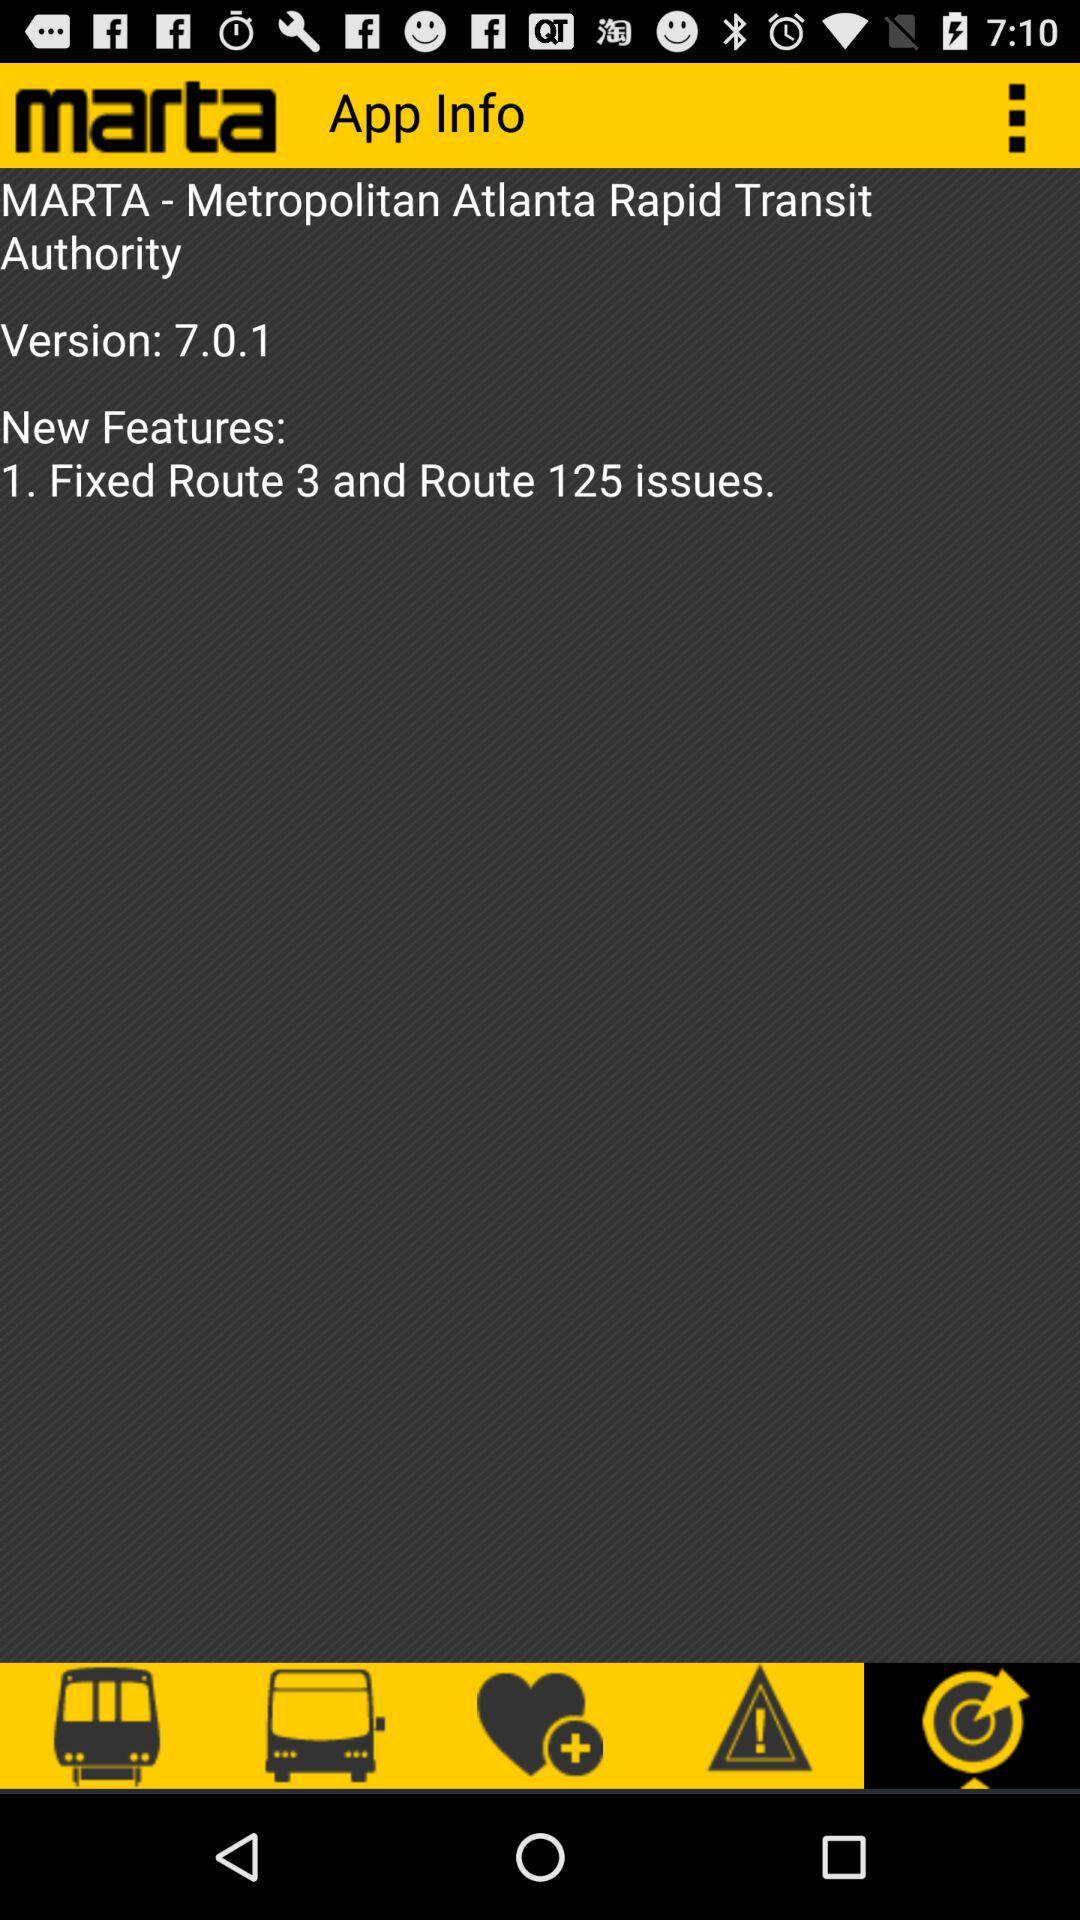What is the application name? The application name is "marta". 